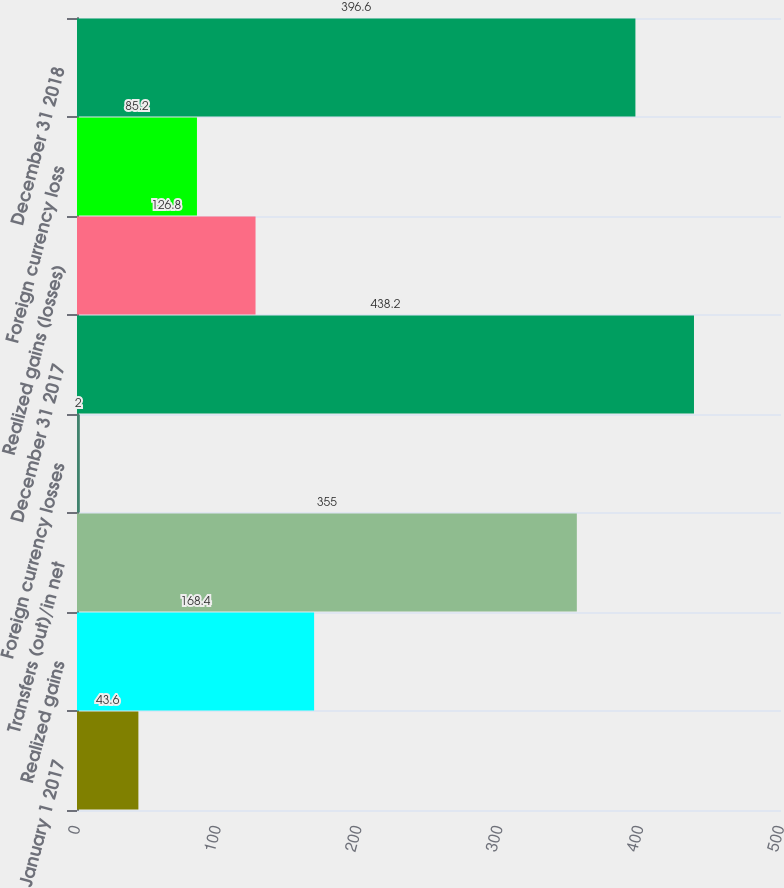<chart> <loc_0><loc_0><loc_500><loc_500><bar_chart><fcel>January 1 2017<fcel>Realized gains<fcel>Transfers (out)/in net<fcel>Foreign currency losses<fcel>December 31 2017<fcel>Realized gains (losses)<fcel>Foreign currency loss<fcel>December 31 2018<nl><fcel>43.6<fcel>168.4<fcel>355<fcel>2<fcel>438.2<fcel>126.8<fcel>85.2<fcel>396.6<nl></chart> 